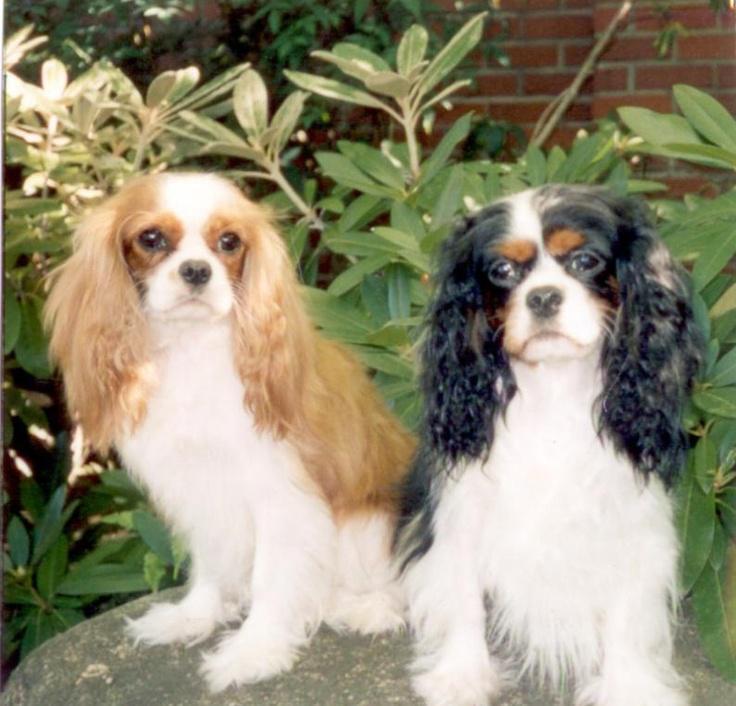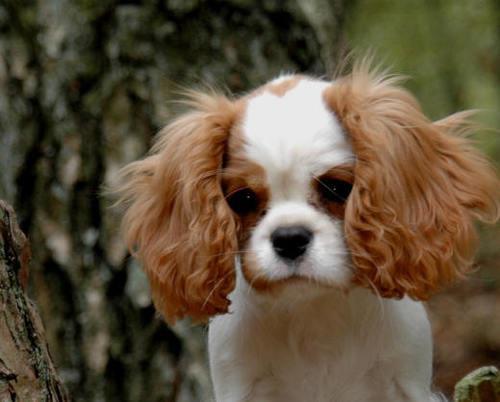The first image is the image on the left, the second image is the image on the right. Considering the images on both sides, is "ther is at least one dog on a stone surface with greenery in the background" valid? Answer yes or no. Yes. 